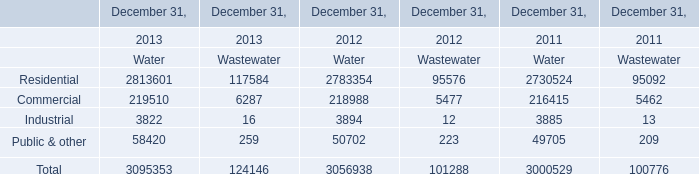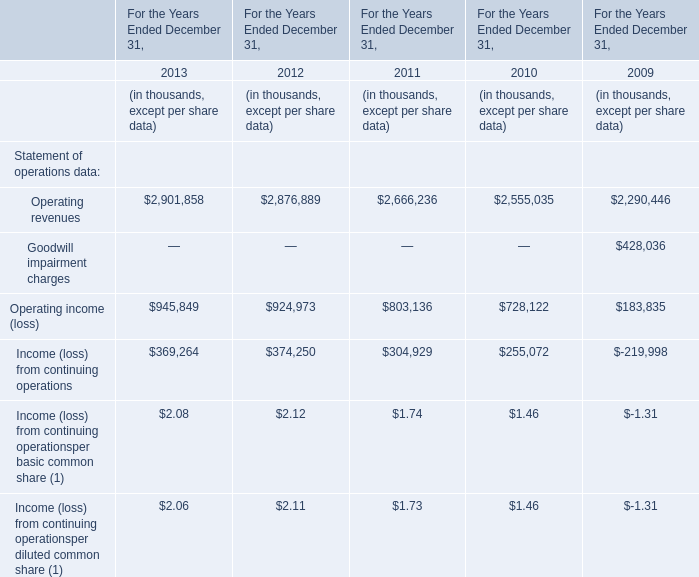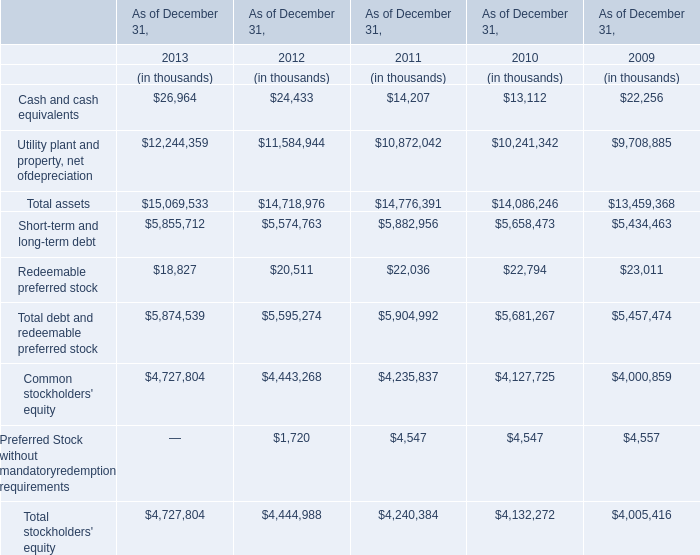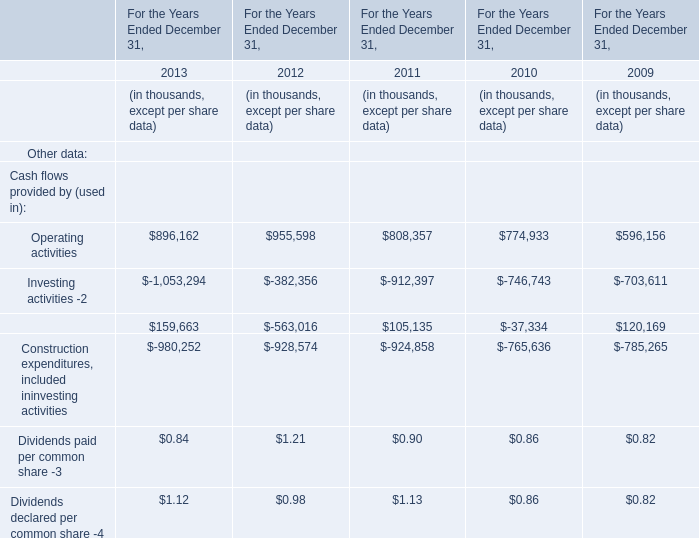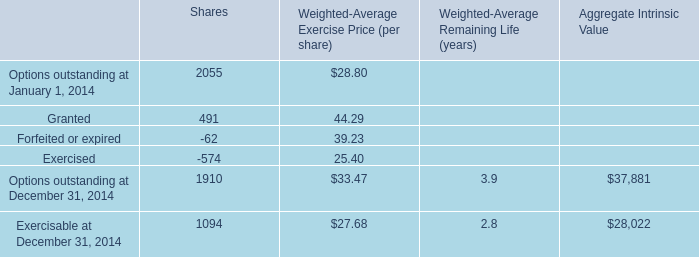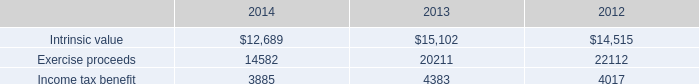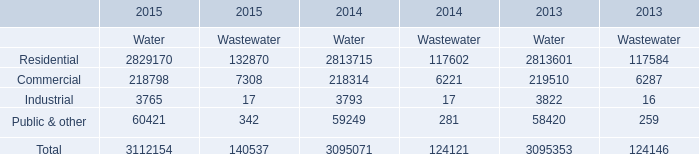What's the sum of Income tax benefit of 2012, and Options outstanding at December 31, 2014 of Shares ? 
Computations: (4017.0 + 1910.0)
Answer: 5927.0. 